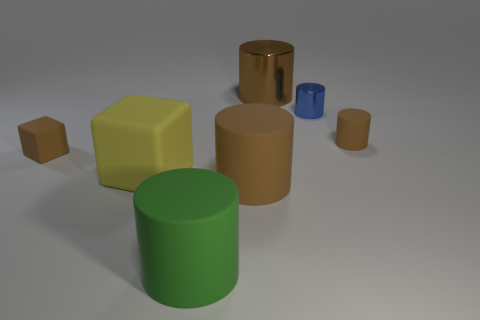Subtract all green cylinders. How many cylinders are left? 4 Subtract all green cylinders. How many cylinders are left? 4 Subtract all blue balls. How many brown cylinders are left? 3 Subtract all green cylinders. Subtract all yellow blocks. How many cylinders are left? 4 Add 2 blue objects. How many objects exist? 9 Subtract all cylinders. How many objects are left? 2 Add 7 big yellow metallic spheres. How many big yellow metallic spheres exist? 7 Subtract 0 gray spheres. How many objects are left? 7 Subtract all small red matte cylinders. Subtract all large rubber objects. How many objects are left? 4 Add 3 big matte things. How many big matte things are left? 6 